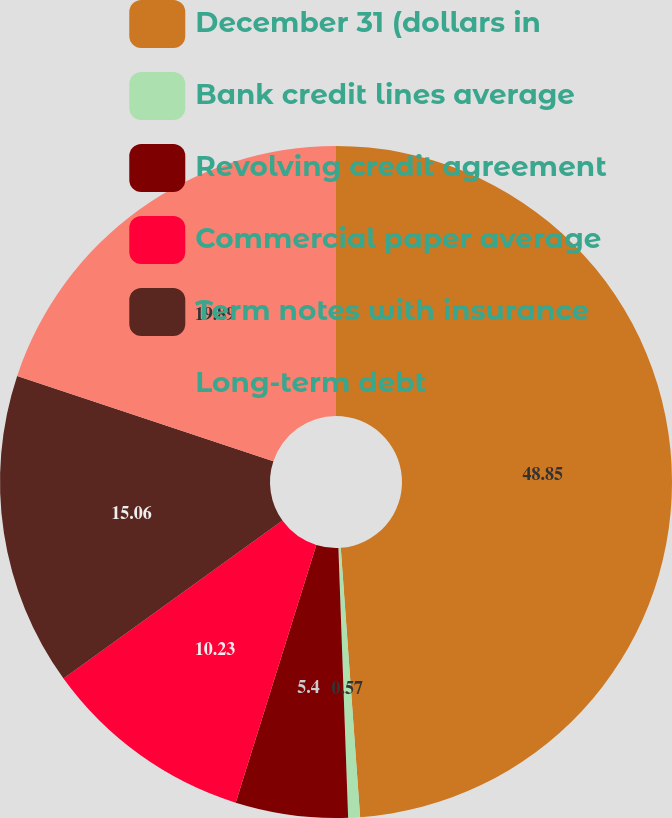Convert chart. <chart><loc_0><loc_0><loc_500><loc_500><pie_chart><fcel>December 31 (dollars in<fcel>Bank credit lines average<fcel>Revolving credit agreement<fcel>Commercial paper average<fcel>Term notes with insurance<fcel>Long-term debt<nl><fcel>48.86%<fcel>0.57%<fcel>5.4%<fcel>10.23%<fcel>15.06%<fcel>19.89%<nl></chart> 